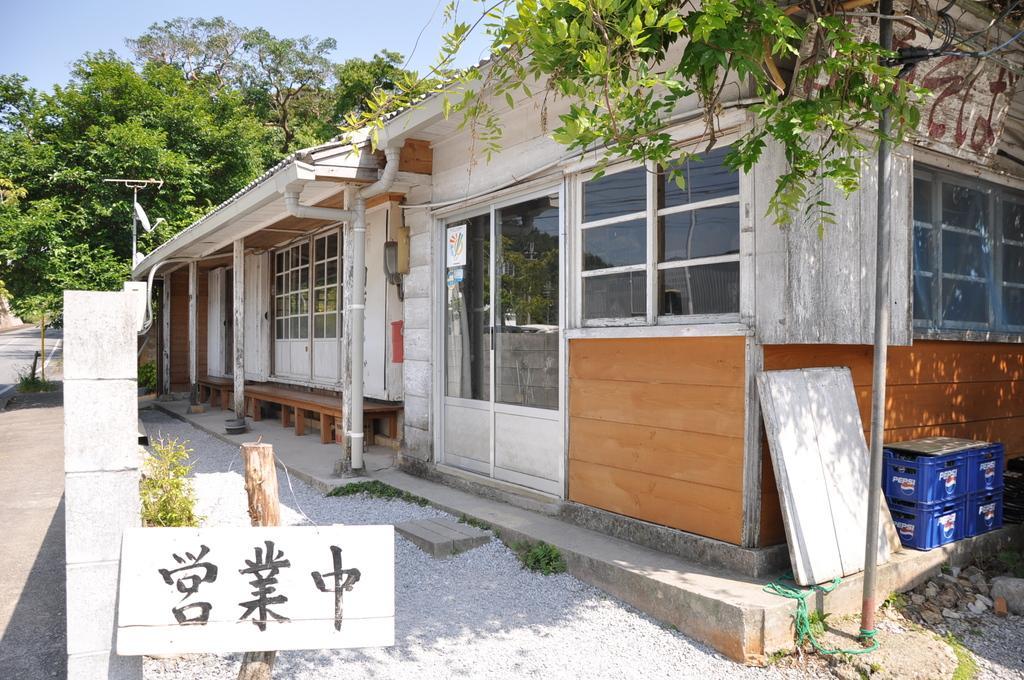How would you summarize this image in a sentence or two? In the image we can see there are buildings and there are trees. There are hoardings kept on the ground and the matter is written in chinese language. There are boxes kept on the ground and there are iron poles. There is a clear sky. 